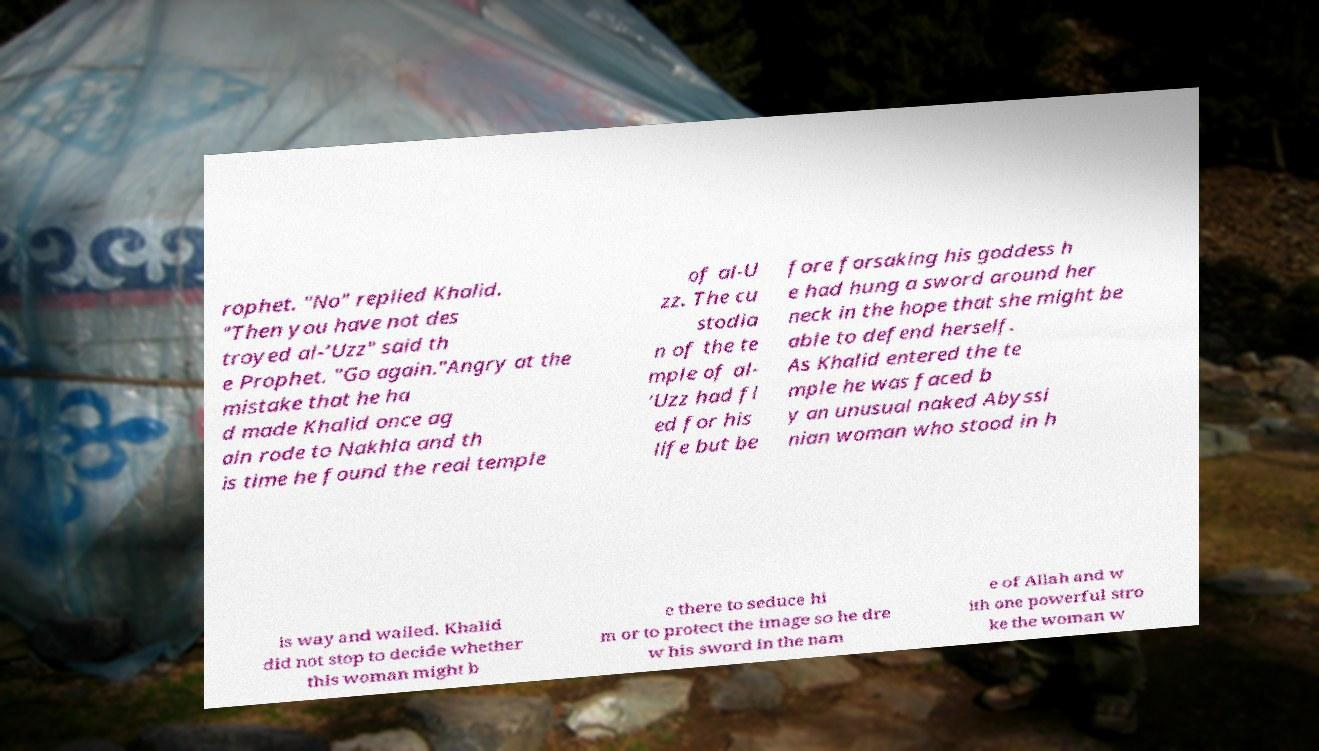For documentation purposes, I need the text within this image transcribed. Could you provide that? rophet. "No" replied Khalid. "Then you have not des troyed al-‘Uzz" said th e Prophet. "Go again."Angry at the mistake that he ha d made Khalid once ag ain rode to Nakhla and th is time he found the real temple of al-U zz. The cu stodia n of the te mple of al- ‘Uzz had fl ed for his life but be fore forsaking his goddess h e had hung a sword around her neck in the hope that she might be able to defend herself. As Khalid entered the te mple he was faced b y an unusual naked Abyssi nian woman who stood in h is way and wailed. Khalid did not stop to decide whether this woman might b e there to seduce hi m or to protect the image so he dre w his sword in the nam e of Allah and w ith one powerful stro ke the woman w 